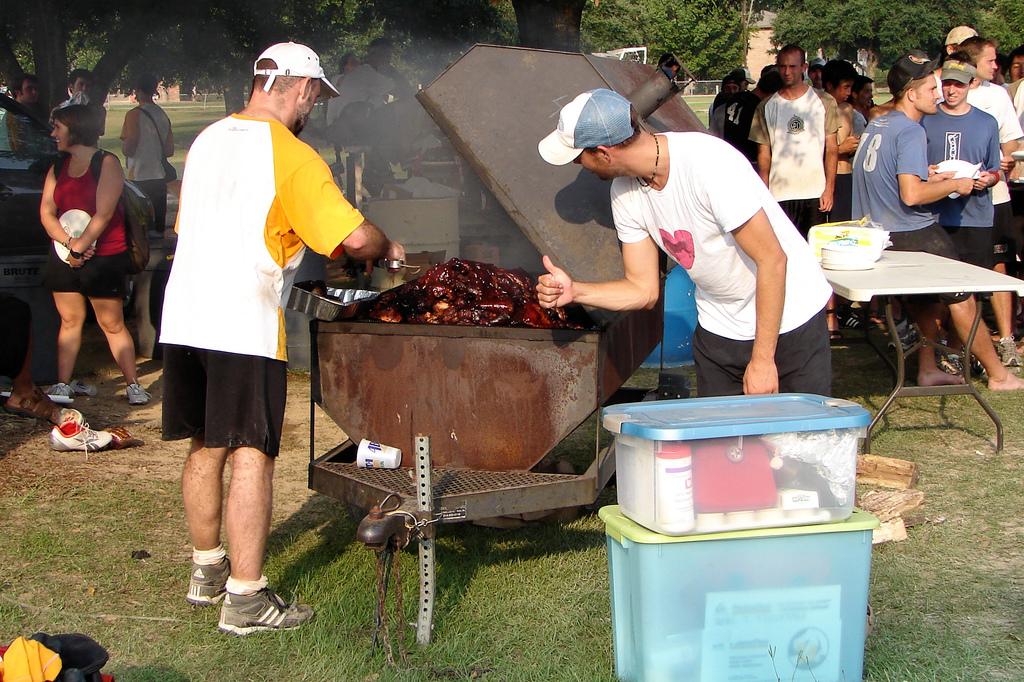What is the second number on the back of the blue shirt?
Provide a short and direct response. 8. 